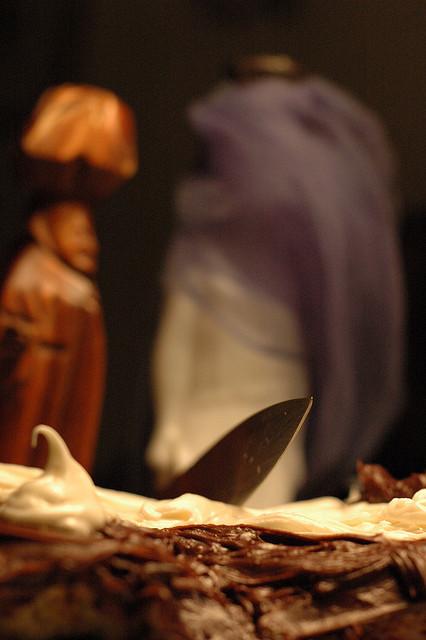What is the object on the left?
Short answer required. Statue. Is this image sharp?
Answer briefly. No. What flavor of frosting is at the very bottom of the image?
Give a very brief answer. Chocolate. 